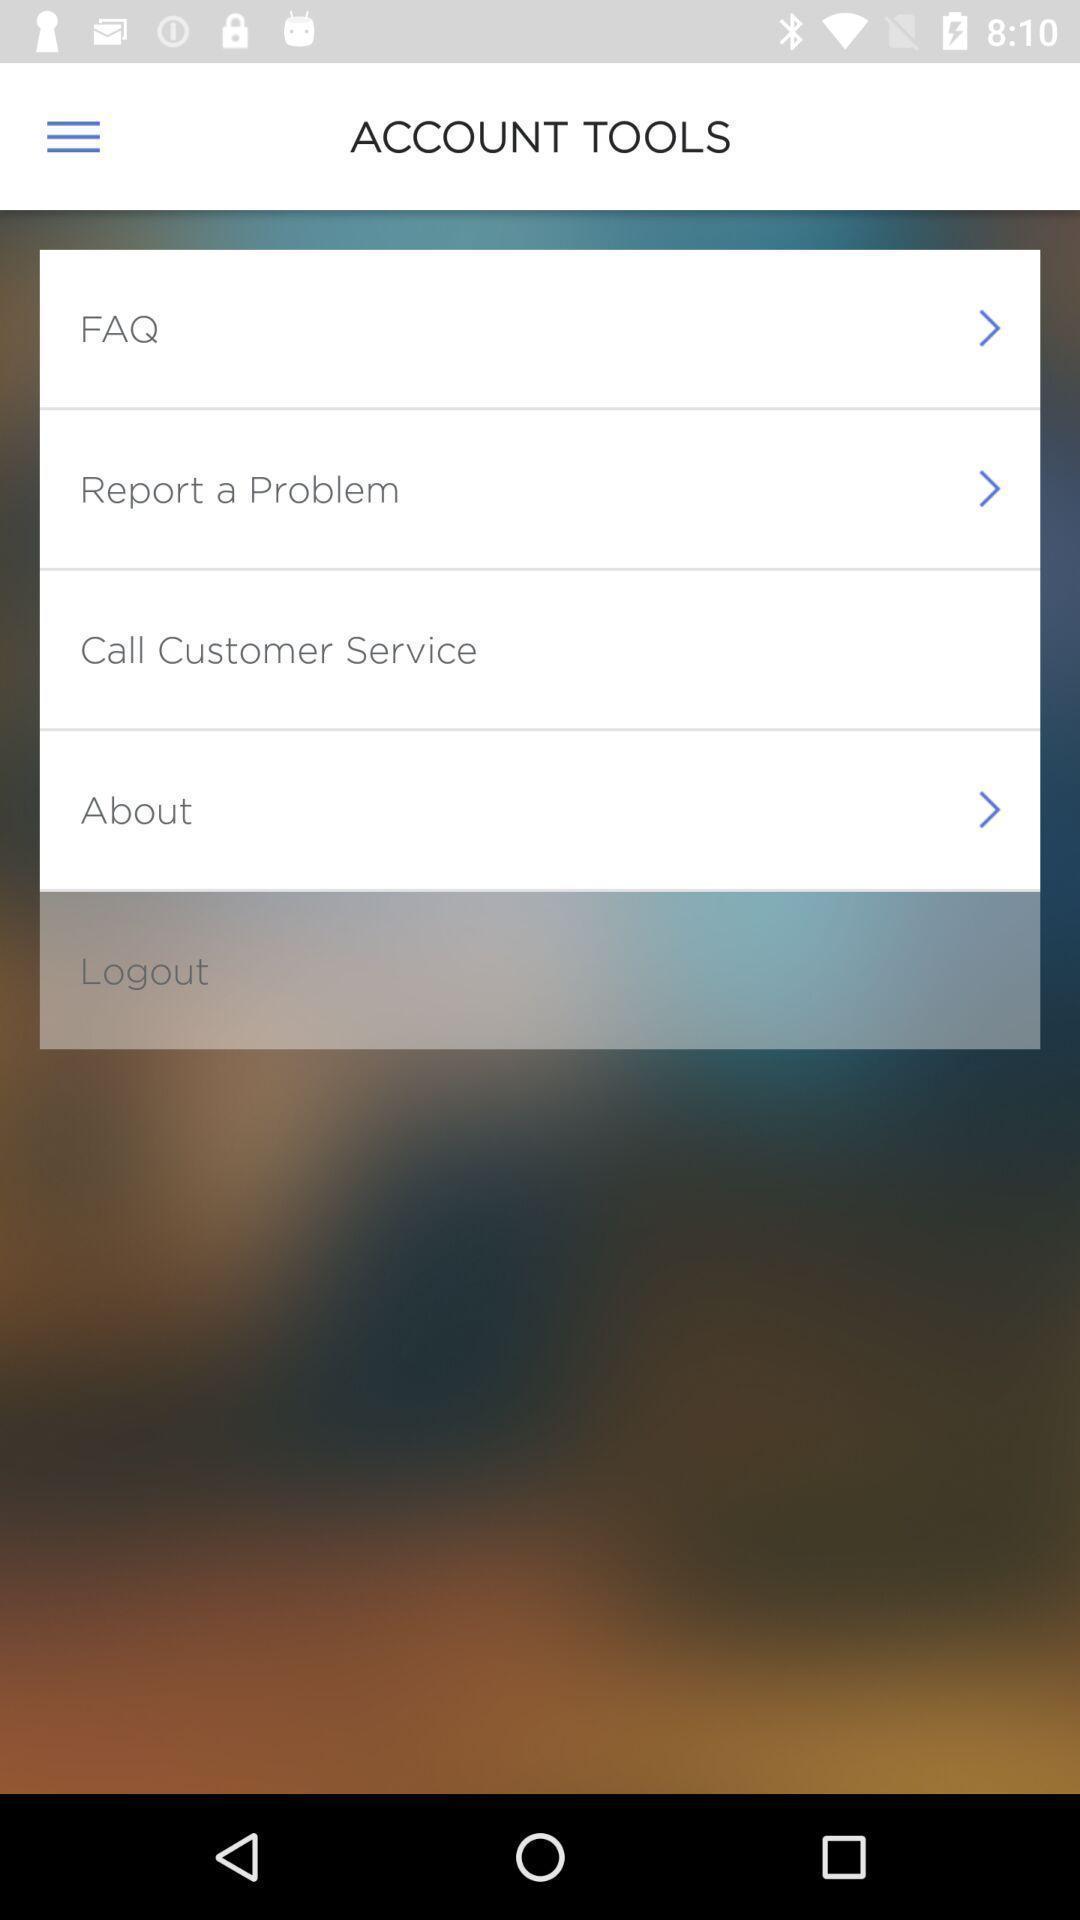What can you discern from this picture? Screen shows list of account tools. 